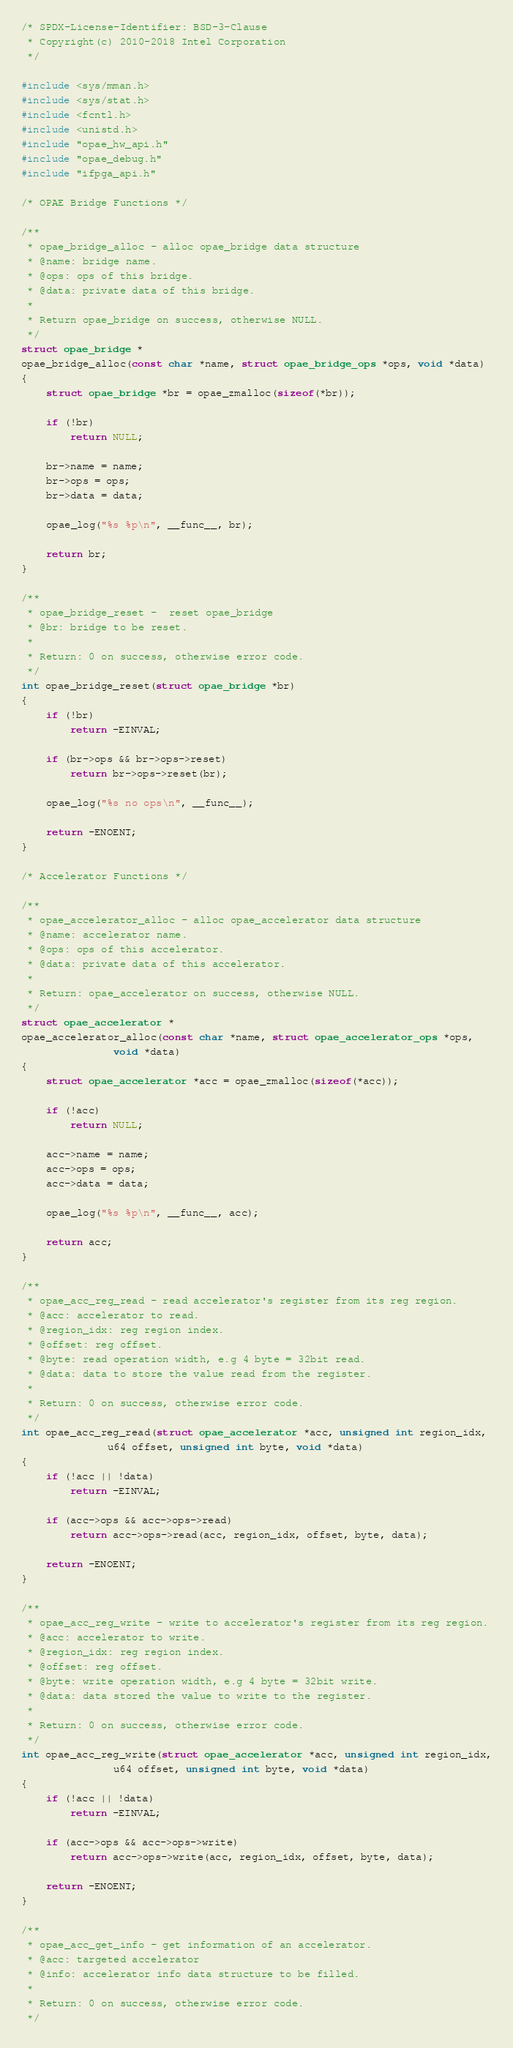Convert code to text. <code><loc_0><loc_0><loc_500><loc_500><_C_>/* SPDX-License-Identifier: BSD-3-Clause
 * Copyright(c) 2010-2018 Intel Corporation
 */

#include <sys/mman.h>
#include <sys/stat.h>
#include <fcntl.h>
#include <unistd.h>
#include "opae_hw_api.h"
#include "opae_debug.h"
#include "ifpga_api.h"

/* OPAE Bridge Functions */

/**
 * opae_bridge_alloc - alloc opae_bridge data structure
 * @name: bridge name.
 * @ops: ops of this bridge.
 * @data: private data of this bridge.
 *
 * Return opae_bridge on success, otherwise NULL.
 */
struct opae_bridge *
opae_bridge_alloc(const char *name, struct opae_bridge_ops *ops, void *data)
{
	struct opae_bridge *br = opae_zmalloc(sizeof(*br));

	if (!br)
		return NULL;

	br->name = name;
	br->ops = ops;
	br->data = data;

	opae_log("%s %p\n", __func__, br);

	return br;
}

/**
 * opae_bridge_reset -  reset opae_bridge
 * @br: bridge to be reset.
 *
 * Return: 0 on success, otherwise error code.
 */
int opae_bridge_reset(struct opae_bridge *br)
{
	if (!br)
		return -EINVAL;

	if (br->ops && br->ops->reset)
		return br->ops->reset(br);

	opae_log("%s no ops\n", __func__);

	return -ENOENT;
}

/* Accelerator Functions */

/**
 * opae_accelerator_alloc - alloc opae_accelerator data structure
 * @name: accelerator name.
 * @ops: ops of this accelerator.
 * @data: private data of this accelerator.
 *
 * Return: opae_accelerator on success, otherwise NULL.
 */
struct opae_accelerator *
opae_accelerator_alloc(const char *name, struct opae_accelerator_ops *ops,
		       void *data)
{
	struct opae_accelerator *acc = opae_zmalloc(sizeof(*acc));

	if (!acc)
		return NULL;

	acc->name = name;
	acc->ops = ops;
	acc->data = data;

	opae_log("%s %p\n", __func__, acc);

	return acc;
}

/**
 * opae_acc_reg_read - read accelerator's register from its reg region.
 * @acc: accelerator to read.
 * @region_idx: reg region index.
 * @offset: reg offset.
 * @byte: read operation width, e.g 4 byte = 32bit read.
 * @data: data to store the value read from the register.
 *
 * Return: 0 on success, otherwise error code.
 */
int opae_acc_reg_read(struct opae_accelerator *acc, unsigned int region_idx,
		      u64 offset, unsigned int byte, void *data)
{
	if (!acc || !data)
		return -EINVAL;

	if (acc->ops && acc->ops->read)
		return acc->ops->read(acc, region_idx, offset, byte, data);

	return -ENOENT;
}

/**
 * opae_acc_reg_write - write to accelerator's register from its reg region.
 * @acc: accelerator to write.
 * @region_idx: reg region index.
 * @offset: reg offset.
 * @byte: write operation width, e.g 4 byte = 32bit write.
 * @data: data stored the value to write to the register.
 *
 * Return: 0 on success, otherwise error code.
 */
int opae_acc_reg_write(struct opae_accelerator *acc, unsigned int region_idx,
		       u64 offset, unsigned int byte, void *data)
{
	if (!acc || !data)
		return -EINVAL;

	if (acc->ops && acc->ops->write)
		return acc->ops->write(acc, region_idx, offset, byte, data);

	return -ENOENT;
}

/**
 * opae_acc_get_info - get information of an accelerator.
 * @acc: targeted accelerator
 * @info: accelerator info data structure to be filled.
 *
 * Return: 0 on success, otherwise error code.
 */</code> 